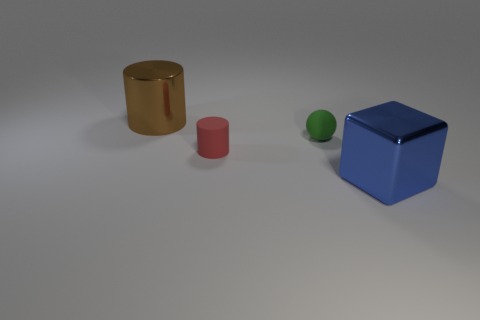Subtract all gray blocks. Subtract all green balls. How many blocks are left? 1 Add 1 small matte balls. How many objects exist? 5 Subtract all blocks. How many objects are left? 3 Add 1 tiny yellow matte cylinders. How many tiny yellow matte cylinders exist? 1 Subtract 0 purple spheres. How many objects are left? 4 Subtract all shiny things. Subtract all cylinders. How many objects are left? 0 Add 2 green matte objects. How many green matte objects are left? 3 